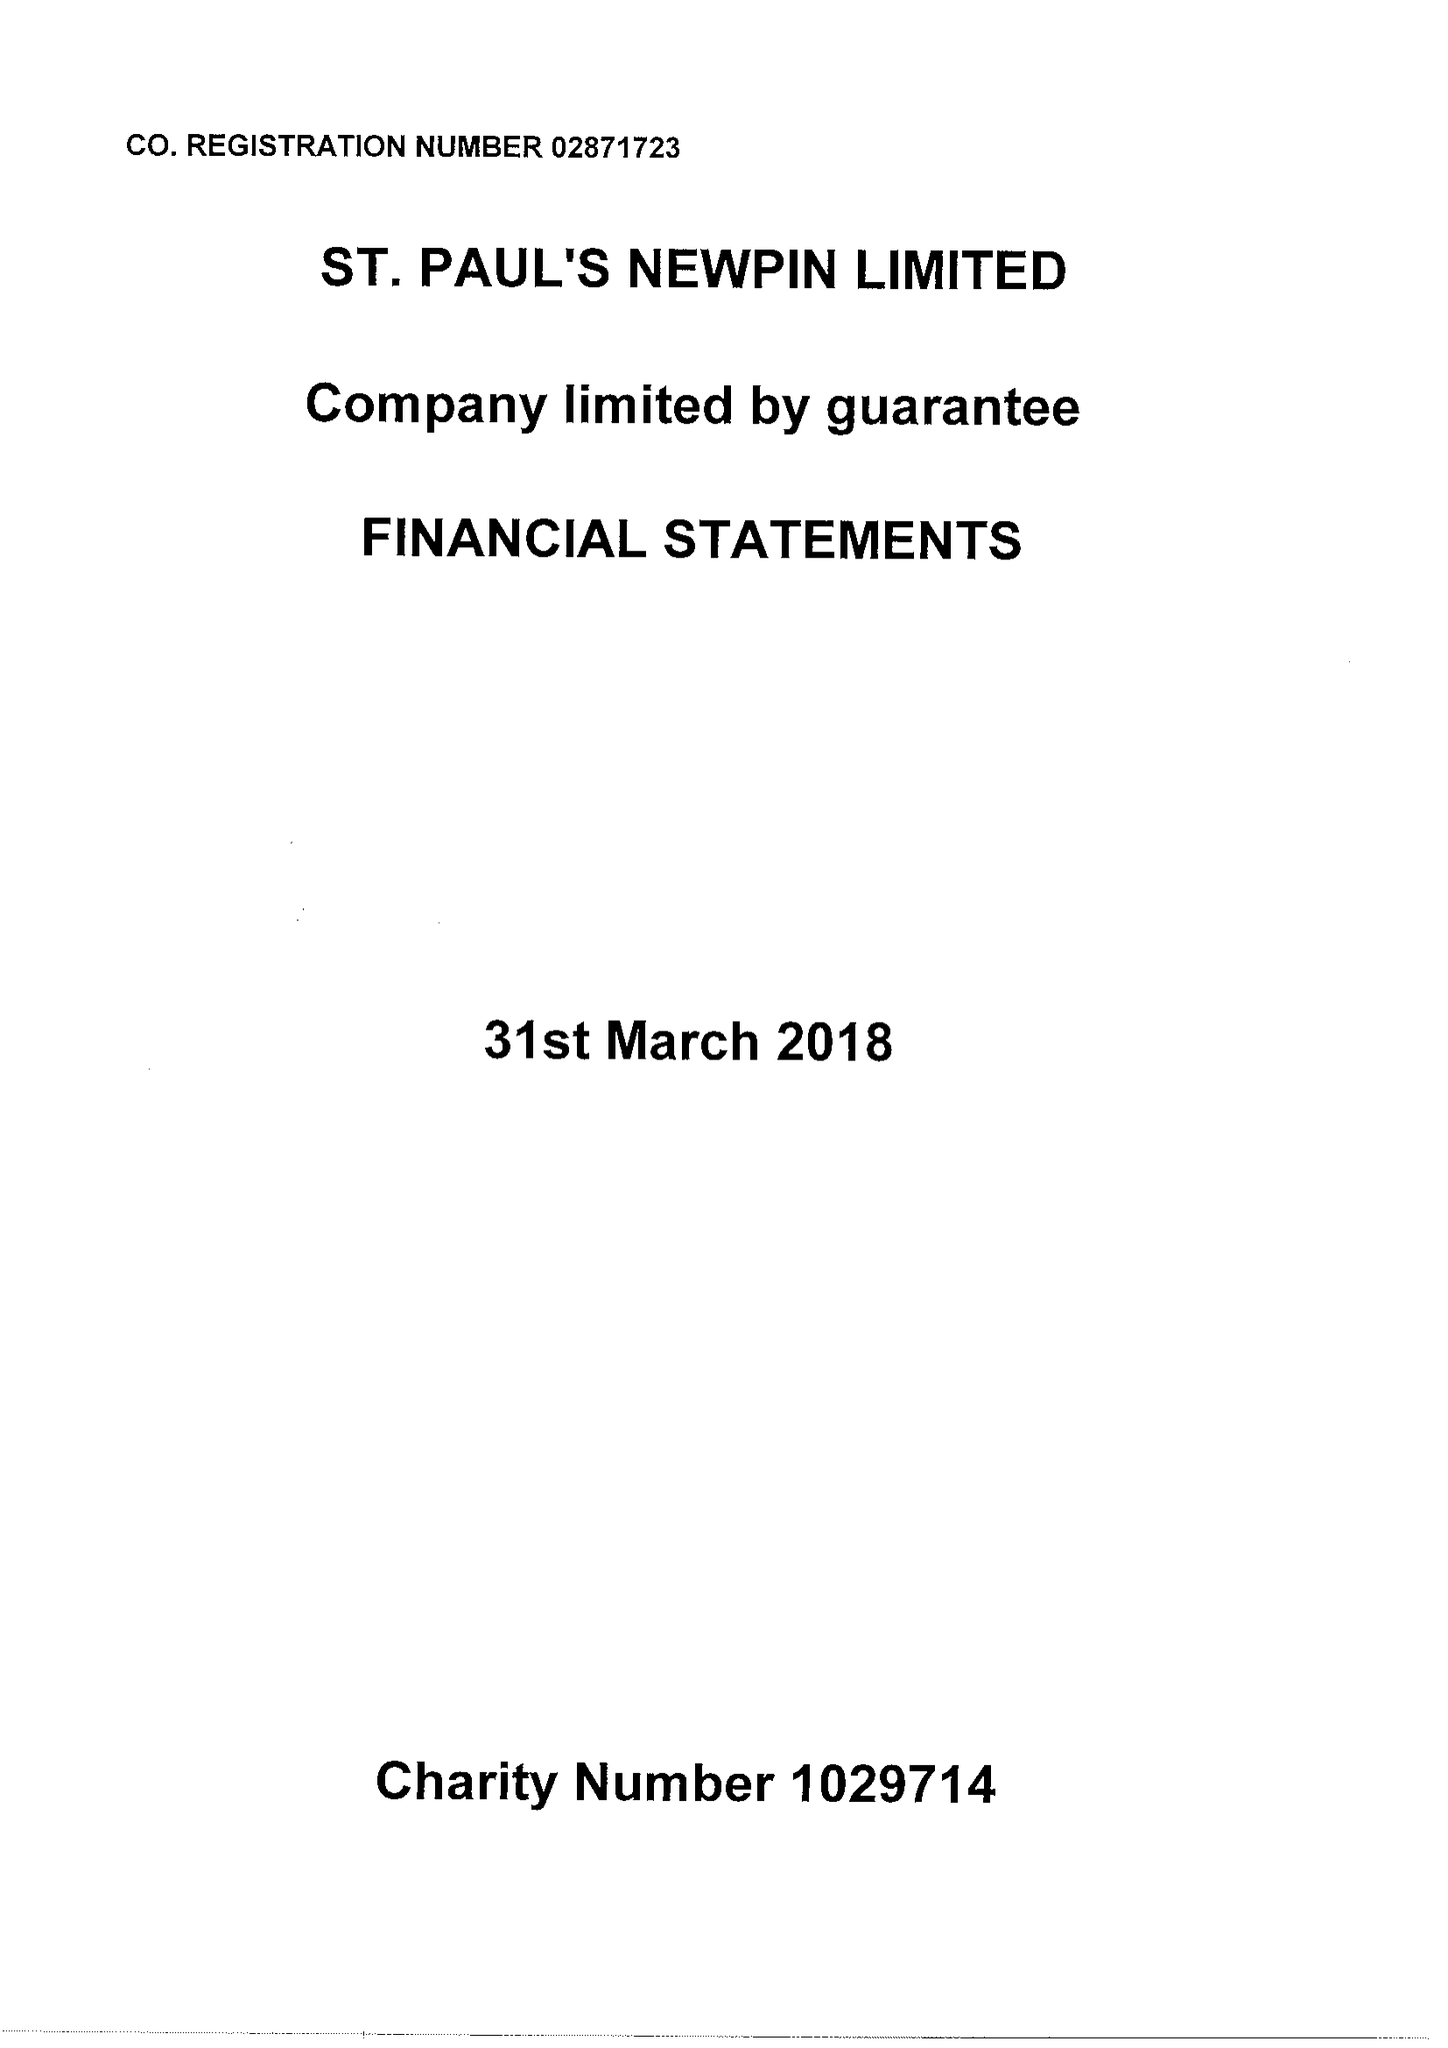What is the value for the address__post_town?
Answer the question using a single word or phrase. LONDON 